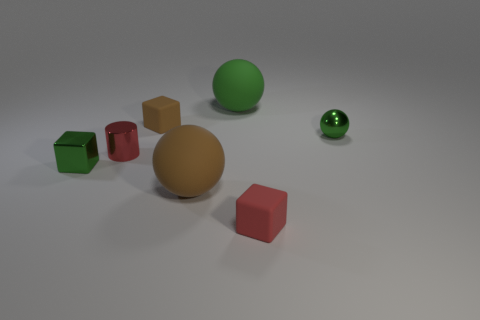Subtract all brown matte balls. How many balls are left? 2 Subtract all red cubes. How many cubes are left? 2 Add 3 large things. How many objects exist? 10 Subtract all balls. How many objects are left? 4 Subtract 2 cubes. How many cubes are left? 1 Subtract all purple spheres. Subtract all red blocks. How many spheres are left? 3 Subtract all brown spheres. How many brown blocks are left? 1 Subtract all big yellow metal balls. Subtract all matte balls. How many objects are left? 5 Add 6 big rubber balls. How many big rubber balls are left? 8 Add 3 red cubes. How many red cubes exist? 4 